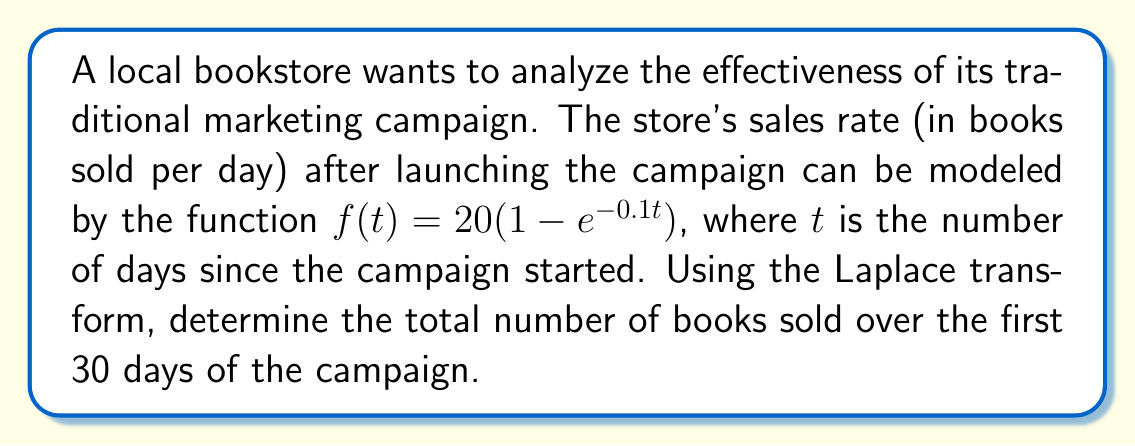Provide a solution to this math problem. To solve this problem, we'll follow these steps:

1) First, we need to find the Laplace transform of the sales rate function $f(t)$.

   $\mathcal{L}\{f(t)\} = \mathcal{L}\{20(1 - e^{-0.1t})\}$
   
   $= 20\mathcal{L}\{1\} - 20\mathcal{L}\{e^{-0.1t}\}$
   
   $= \frac{20}{s} - \frac{20}{s+0.1}$
   
   $= \frac{20(s+0.1) - 20s}{s(s+0.1)}$
   
   $= \frac{2}{s(s+0.1)}$

2) To find the total number of books sold, we need to integrate the sales rate from 0 to 30. In the Laplace domain, this is equivalent to multiplying by $\frac{1}{s}$ and then finding the inverse Laplace transform.

   $\mathcal{L}\{\int_0^t f(\tau)d\tau\} = \frac{1}{s} \cdot \frac{2}{s(s+0.1)}$
   
   $= \frac{2}{s^2(s+0.1)}$

3) Now we need to find the inverse Laplace transform of this function. We can use partial fraction decomposition:

   $\frac{2}{s^2(s+0.1)} = \frac{A}{s} + \frac{B}{s^2} + \frac{C}{s+0.1}$

   Solving for A, B, and C:
   
   $A = -200$
   $B = 200$
   $C = 200$

4) So, we have:

   $\mathcal{L}^{-1}\{\frac{2}{s^2(s+0.1)}\} = -200\mathcal{L}^{-1}\{\frac{1}{s}\} + 200\mathcal{L}^{-1}\{\frac{1}{s^2}\} + 200\mathcal{L}^{-1}\{\frac{1}{s+0.1}\}$
   
   $= -200 + 200t + 2000(1-e^{-0.1t})$

5) Finally, we evaluate this at t = 30:

   $-200 + 200(30) + 2000(1-e^{-0.1(30)})$
   
   $= -200 + 6000 + 2000(1-e^{-3})$
   
   $\approx 7800 - 100 = 7700$

Therefore, approximately 7700 books were sold over the first 30 days of the campaign.
Answer: Approximately 7700 books 